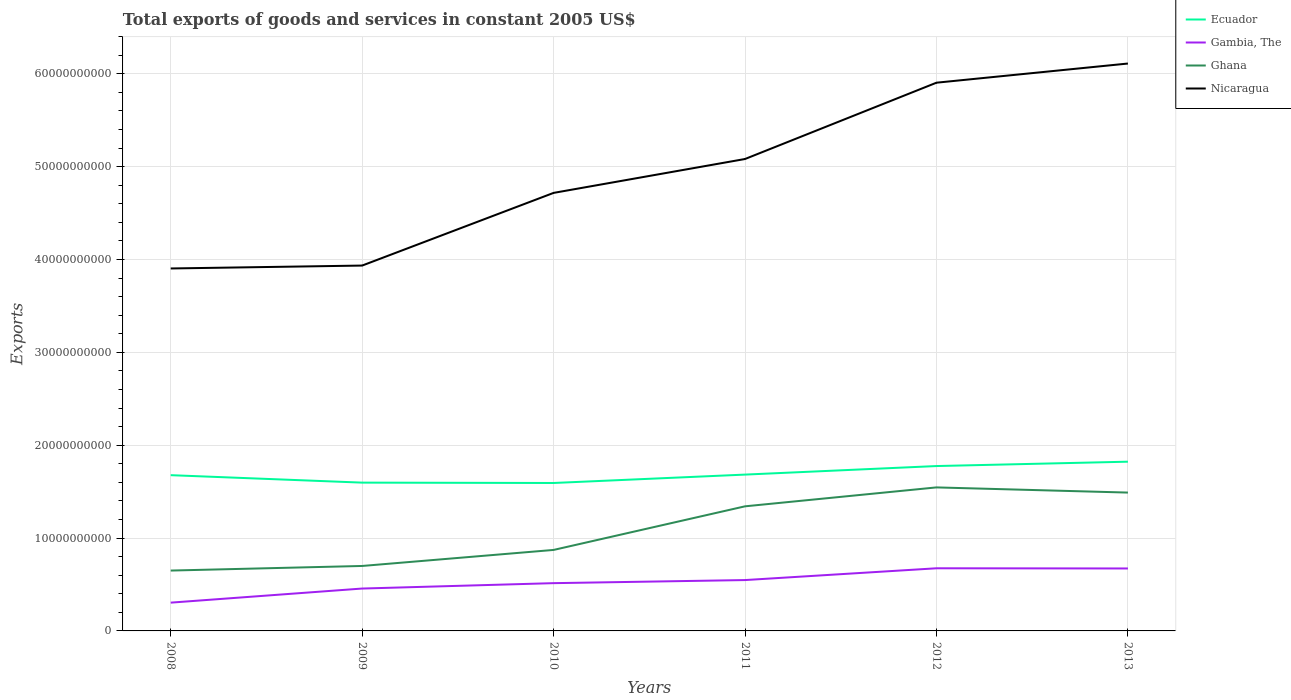Does the line corresponding to Nicaragua intersect with the line corresponding to Gambia, The?
Your response must be concise. No. Is the number of lines equal to the number of legend labels?
Your response must be concise. Yes. Across all years, what is the maximum total exports of goods and services in Ecuador?
Offer a very short reply. 1.59e+1. What is the total total exports of goods and services in Ecuador in the graph?
Your answer should be very brief. -1.39e+09. What is the difference between the highest and the second highest total exports of goods and services in Ecuador?
Provide a succinct answer. 2.29e+09. Is the total exports of goods and services in Ecuador strictly greater than the total exports of goods and services in Nicaragua over the years?
Offer a very short reply. Yes. How many lines are there?
Give a very brief answer. 4. Are the values on the major ticks of Y-axis written in scientific E-notation?
Ensure brevity in your answer.  No. Does the graph contain grids?
Your answer should be compact. Yes. Where does the legend appear in the graph?
Offer a terse response. Top right. What is the title of the graph?
Provide a succinct answer. Total exports of goods and services in constant 2005 US$. Does "Kyrgyz Republic" appear as one of the legend labels in the graph?
Your response must be concise. No. What is the label or title of the X-axis?
Keep it short and to the point. Years. What is the label or title of the Y-axis?
Provide a short and direct response. Exports. What is the Exports of Ecuador in 2008?
Keep it short and to the point. 1.68e+1. What is the Exports in Gambia, The in 2008?
Make the answer very short. 3.05e+09. What is the Exports in Ghana in 2008?
Make the answer very short. 6.50e+09. What is the Exports in Nicaragua in 2008?
Provide a short and direct response. 3.90e+1. What is the Exports of Ecuador in 2009?
Your response must be concise. 1.60e+1. What is the Exports in Gambia, The in 2009?
Your answer should be very brief. 4.56e+09. What is the Exports in Ghana in 2009?
Your response must be concise. 7.00e+09. What is the Exports of Nicaragua in 2009?
Ensure brevity in your answer.  3.93e+1. What is the Exports of Ecuador in 2010?
Your answer should be compact. 1.59e+1. What is the Exports of Gambia, The in 2010?
Keep it short and to the point. 5.14e+09. What is the Exports in Ghana in 2010?
Ensure brevity in your answer.  8.72e+09. What is the Exports in Nicaragua in 2010?
Your answer should be very brief. 4.72e+1. What is the Exports of Ecuador in 2011?
Your response must be concise. 1.68e+1. What is the Exports of Gambia, The in 2011?
Your answer should be compact. 5.48e+09. What is the Exports of Ghana in 2011?
Your answer should be compact. 1.34e+1. What is the Exports in Nicaragua in 2011?
Offer a terse response. 5.08e+1. What is the Exports in Ecuador in 2012?
Your answer should be very brief. 1.78e+1. What is the Exports of Gambia, The in 2012?
Provide a short and direct response. 6.75e+09. What is the Exports of Ghana in 2012?
Provide a short and direct response. 1.55e+1. What is the Exports in Nicaragua in 2012?
Offer a terse response. 5.90e+1. What is the Exports in Ecuador in 2013?
Offer a terse response. 1.82e+1. What is the Exports in Gambia, The in 2013?
Make the answer very short. 6.73e+09. What is the Exports in Ghana in 2013?
Provide a short and direct response. 1.49e+1. What is the Exports of Nicaragua in 2013?
Make the answer very short. 6.11e+1. Across all years, what is the maximum Exports in Ecuador?
Offer a very short reply. 1.82e+1. Across all years, what is the maximum Exports of Gambia, The?
Your response must be concise. 6.75e+09. Across all years, what is the maximum Exports in Ghana?
Your response must be concise. 1.55e+1. Across all years, what is the maximum Exports of Nicaragua?
Give a very brief answer. 6.11e+1. Across all years, what is the minimum Exports of Ecuador?
Keep it short and to the point. 1.59e+1. Across all years, what is the minimum Exports in Gambia, The?
Your answer should be very brief. 3.05e+09. Across all years, what is the minimum Exports of Ghana?
Ensure brevity in your answer.  6.50e+09. Across all years, what is the minimum Exports in Nicaragua?
Offer a very short reply. 3.90e+1. What is the total Exports in Ecuador in the graph?
Keep it short and to the point. 1.01e+11. What is the total Exports of Gambia, The in the graph?
Your response must be concise. 3.17e+1. What is the total Exports of Ghana in the graph?
Keep it short and to the point. 6.60e+1. What is the total Exports of Nicaragua in the graph?
Offer a very short reply. 2.97e+11. What is the difference between the Exports of Ecuador in 2008 and that in 2009?
Provide a short and direct response. 8.03e+08. What is the difference between the Exports of Gambia, The in 2008 and that in 2009?
Keep it short and to the point. -1.52e+09. What is the difference between the Exports of Ghana in 2008 and that in 2009?
Provide a succinct answer. -4.95e+08. What is the difference between the Exports in Nicaragua in 2008 and that in 2009?
Offer a terse response. -3.12e+08. What is the difference between the Exports of Ecuador in 2008 and that in 2010?
Offer a very short reply. 8.41e+08. What is the difference between the Exports of Gambia, The in 2008 and that in 2010?
Ensure brevity in your answer.  -2.10e+09. What is the difference between the Exports in Ghana in 2008 and that in 2010?
Your answer should be very brief. -2.22e+09. What is the difference between the Exports of Nicaragua in 2008 and that in 2010?
Your response must be concise. -8.14e+09. What is the difference between the Exports of Ecuador in 2008 and that in 2011?
Offer a terse response. -6.20e+07. What is the difference between the Exports in Gambia, The in 2008 and that in 2011?
Your answer should be very brief. -2.43e+09. What is the difference between the Exports in Ghana in 2008 and that in 2011?
Provide a short and direct response. -6.92e+09. What is the difference between the Exports in Nicaragua in 2008 and that in 2011?
Make the answer very short. -1.18e+1. What is the difference between the Exports of Ecuador in 2008 and that in 2012?
Your response must be concise. -9.82e+08. What is the difference between the Exports of Gambia, The in 2008 and that in 2012?
Provide a succinct answer. -3.70e+09. What is the difference between the Exports of Ghana in 2008 and that in 2012?
Offer a very short reply. -8.96e+09. What is the difference between the Exports in Nicaragua in 2008 and that in 2012?
Offer a very short reply. -2.00e+1. What is the difference between the Exports of Ecuador in 2008 and that in 2013?
Your answer should be very brief. -1.45e+09. What is the difference between the Exports in Gambia, The in 2008 and that in 2013?
Provide a succinct answer. -3.68e+09. What is the difference between the Exports of Ghana in 2008 and that in 2013?
Provide a succinct answer. -8.40e+09. What is the difference between the Exports in Nicaragua in 2008 and that in 2013?
Provide a succinct answer. -2.21e+1. What is the difference between the Exports in Ecuador in 2009 and that in 2010?
Give a very brief answer. 3.79e+07. What is the difference between the Exports of Gambia, The in 2009 and that in 2010?
Offer a terse response. -5.81e+08. What is the difference between the Exports of Ghana in 2009 and that in 2010?
Offer a terse response. -1.73e+09. What is the difference between the Exports of Nicaragua in 2009 and that in 2010?
Make the answer very short. -7.83e+09. What is the difference between the Exports of Ecuador in 2009 and that in 2011?
Your answer should be very brief. -8.65e+08. What is the difference between the Exports in Gambia, The in 2009 and that in 2011?
Offer a terse response. -9.14e+08. What is the difference between the Exports of Ghana in 2009 and that in 2011?
Give a very brief answer. -6.42e+09. What is the difference between the Exports of Nicaragua in 2009 and that in 2011?
Offer a very short reply. -1.15e+1. What is the difference between the Exports in Ecuador in 2009 and that in 2012?
Ensure brevity in your answer.  -1.79e+09. What is the difference between the Exports in Gambia, The in 2009 and that in 2012?
Give a very brief answer. -2.18e+09. What is the difference between the Exports in Ghana in 2009 and that in 2012?
Keep it short and to the point. -8.46e+09. What is the difference between the Exports in Nicaragua in 2009 and that in 2012?
Offer a terse response. -1.97e+1. What is the difference between the Exports of Ecuador in 2009 and that in 2013?
Your answer should be very brief. -2.26e+09. What is the difference between the Exports in Gambia, The in 2009 and that in 2013?
Provide a short and direct response. -2.16e+09. What is the difference between the Exports of Ghana in 2009 and that in 2013?
Keep it short and to the point. -7.90e+09. What is the difference between the Exports in Nicaragua in 2009 and that in 2013?
Your answer should be compact. -2.18e+1. What is the difference between the Exports of Ecuador in 2010 and that in 2011?
Make the answer very short. -9.03e+08. What is the difference between the Exports in Gambia, The in 2010 and that in 2011?
Your answer should be compact. -3.33e+08. What is the difference between the Exports in Ghana in 2010 and that in 2011?
Keep it short and to the point. -4.70e+09. What is the difference between the Exports of Nicaragua in 2010 and that in 2011?
Ensure brevity in your answer.  -3.65e+09. What is the difference between the Exports of Ecuador in 2010 and that in 2012?
Make the answer very short. -1.82e+09. What is the difference between the Exports in Gambia, The in 2010 and that in 2012?
Provide a short and direct response. -1.60e+09. What is the difference between the Exports of Ghana in 2010 and that in 2012?
Your answer should be compact. -6.73e+09. What is the difference between the Exports in Nicaragua in 2010 and that in 2012?
Provide a succinct answer. -1.19e+1. What is the difference between the Exports in Ecuador in 2010 and that in 2013?
Your response must be concise. -2.29e+09. What is the difference between the Exports of Gambia, The in 2010 and that in 2013?
Offer a terse response. -1.58e+09. What is the difference between the Exports in Ghana in 2010 and that in 2013?
Make the answer very short. -6.18e+09. What is the difference between the Exports in Nicaragua in 2010 and that in 2013?
Ensure brevity in your answer.  -1.39e+1. What is the difference between the Exports in Ecuador in 2011 and that in 2012?
Offer a terse response. -9.20e+08. What is the difference between the Exports in Gambia, The in 2011 and that in 2012?
Ensure brevity in your answer.  -1.27e+09. What is the difference between the Exports in Ghana in 2011 and that in 2012?
Keep it short and to the point. -2.04e+09. What is the difference between the Exports of Nicaragua in 2011 and that in 2012?
Offer a very short reply. -8.22e+09. What is the difference between the Exports in Ecuador in 2011 and that in 2013?
Provide a succinct answer. -1.39e+09. What is the difference between the Exports of Gambia, The in 2011 and that in 2013?
Make the answer very short. -1.25e+09. What is the difference between the Exports of Ghana in 2011 and that in 2013?
Keep it short and to the point. -1.48e+09. What is the difference between the Exports in Nicaragua in 2011 and that in 2013?
Provide a succinct answer. -1.03e+1. What is the difference between the Exports in Ecuador in 2012 and that in 2013?
Offer a terse response. -4.70e+08. What is the difference between the Exports in Ghana in 2012 and that in 2013?
Offer a very short reply. 5.57e+08. What is the difference between the Exports of Nicaragua in 2012 and that in 2013?
Make the answer very short. -2.06e+09. What is the difference between the Exports in Ecuador in 2008 and the Exports in Gambia, The in 2009?
Ensure brevity in your answer.  1.22e+1. What is the difference between the Exports in Ecuador in 2008 and the Exports in Ghana in 2009?
Offer a terse response. 9.78e+09. What is the difference between the Exports of Ecuador in 2008 and the Exports of Nicaragua in 2009?
Your answer should be very brief. -2.26e+1. What is the difference between the Exports of Gambia, The in 2008 and the Exports of Ghana in 2009?
Provide a short and direct response. -3.95e+09. What is the difference between the Exports of Gambia, The in 2008 and the Exports of Nicaragua in 2009?
Offer a terse response. -3.63e+1. What is the difference between the Exports of Ghana in 2008 and the Exports of Nicaragua in 2009?
Provide a succinct answer. -3.28e+1. What is the difference between the Exports in Ecuador in 2008 and the Exports in Gambia, The in 2010?
Make the answer very short. 1.16e+1. What is the difference between the Exports of Ecuador in 2008 and the Exports of Ghana in 2010?
Provide a succinct answer. 8.05e+09. What is the difference between the Exports of Ecuador in 2008 and the Exports of Nicaragua in 2010?
Provide a succinct answer. -3.04e+1. What is the difference between the Exports of Gambia, The in 2008 and the Exports of Ghana in 2010?
Give a very brief answer. -5.68e+09. What is the difference between the Exports in Gambia, The in 2008 and the Exports in Nicaragua in 2010?
Make the answer very short. -4.41e+1. What is the difference between the Exports of Ghana in 2008 and the Exports of Nicaragua in 2010?
Provide a short and direct response. -4.07e+1. What is the difference between the Exports in Ecuador in 2008 and the Exports in Gambia, The in 2011?
Keep it short and to the point. 1.13e+1. What is the difference between the Exports of Ecuador in 2008 and the Exports of Ghana in 2011?
Give a very brief answer. 3.35e+09. What is the difference between the Exports in Ecuador in 2008 and the Exports in Nicaragua in 2011?
Offer a very short reply. -3.41e+1. What is the difference between the Exports of Gambia, The in 2008 and the Exports of Ghana in 2011?
Keep it short and to the point. -1.04e+1. What is the difference between the Exports of Gambia, The in 2008 and the Exports of Nicaragua in 2011?
Your answer should be very brief. -4.78e+1. What is the difference between the Exports in Ghana in 2008 and the Exports in Nicaragua in 2011?
Give a very brief answer. -4.43e+1. What is the difference between the Exports in Ecuador in 2008 and the Exports in Gambia, The in 2012?
Give a very brief answer. 1.00e+1. What is the difference between the Exports in Ecuador in 2008 and the Exports in Ghana in 2012?
Provide a short and direct response. 1.32e+09. What is the difference between the Exports in Ecuador in 2008 and the Exports in Nicaragua in 2012?
Provide a succinct answer. -4.23e+1. What is the difference between the Exports of Gambia, The in 2008 and the Exports of Ghana in 2012?
Your answer should be very brief. -1.24e+1. What is the difference between the Exports of Gambia, The in 2008 and the Exports of Nicaragua in 2012?
Your answer should be very brief. -5.60e+1. What is the difference between the Exports in Ghana in 2008 and the Exports in Nicaragua in 2012?
Your answer should be compact. -5.25e+1. What is the difference between the Exports of Ecuador in 2008 and the Exports of Gambia, The in 2013?
Your response must be concise. 1.00e+1. What is the difference between the Exports in Ecuador in 2008 and the Exports in Ghana in 2013?
Provide a succinct answer. 1.87e+09. What is the difference between the Exports of Ecuador in 2008 and the Exports of Nicaragua in 2013?
Offer a very short reply. -4.43e+1. What is the difference between the Exports in Gambia, The in 2008 and the Exports in Ghana in 2013?
Your answer should be very brief. -1.19e+1. What is the difference between the Exports of Gambia, The in 2008 and the Exports of Nicaragua in 2013?
Offer a terse response. -5.81e+1. What is the difference between the Exports in Ghana in 2008 and the Exports in Nicaragua in 2013?
Your answer should be compact. -5.46e+1. What is the difference between the Exports in Ecuador in 2009 and the Exports in Gambia, The in 2010?
Offer a very short reply. 1.08e+1. What is the difference between the Exports in Ecuador in 2009 and the Exports in Ghana in 2010?
Your answer should be very brief. 7.25e+09. What is the difference between the Exports in Ecuador in 2009 and the Exports in Nicaragua in 2010?
Offer a terse response. -3.12e+1. What is the difference between the Exports in Gambia, The in 2009 and the Exports in Ghana in 2010?
Offer a terse response. -4.16e+09. What is the difference between the Exports of Gambia, The in 2009 and the Exports of Nicaragua in 2010?
Give a very brief answer. -4.26e+1. What is the difference between the Exports in Ghana in 2009 and the Exports in Nicaragua in 2010?
Provide a short and direct response. -4.02e+1. What is the difference between the Exports of Ecuador in 2009 and the Exports of Gambia, The in 2011?
Give a very brief answer. 1.05e+1. What is the difference between the Exports in Ecuador in 2009 and the Exports in Ghana in 2011?
Ensure brevity in your answer.  2.55e+09. What is the difference between the Exports in Ecuador in 2009 and the Exports in Nicaragua in 2011?
Your response must be concise. -3.49e+1. What is the difference between the Exports in Gambia, The in 2009 and the Exports in Ghana in 2011?
Make the answer very short. -8.85e+09. What is the difference between the Exports of Gambia, The in 2009 and the Exports of Nicaragua in 2011?
Provide a short and direct response. -4.63e+1. What is the difference between the Exports in Ghana in 2009 and the Exports in Nicaragua in 2011?
Provide a short and direct response. -4.38e+1. What is the difference between the Exports in Ecuador in 2009 and the Exports in Gambia, The in 2012?
Make the answer very short. 9.22e+09. What is the difference between the Exports in Ecuador in 2009 and the Exports in Ghana in 2012?
Your response must be concise. 5.14e+08. What is the difference between the Exports of Ecuador in 2009 and the Exports of Nicaragua in 2012?
Your answer should be very brief. -4.31e+1. What is the difference between the Exports of Gambia, The in 2009 and the Exports of Ghana in 2012?
Make the answer very short. -1.09e+1. What is the difference between the Exports in Gambia, The in 2009 and the Exports in Nicaragua in 2012?
Provide a short and direct response. -5.45e+1. What is the difference between the Exports of Ghana in 2009 and the Exports of Nicaragua in 2012?
Make the answer very short. -5.20e+1. What is the difference between the Exports of Ecuador in 2009 and the Exports of Gambia, The in 2013?
Give a very brief answer. 9.24e+09. What is the difference between the Exports of Ecuador in 2009 and the Exports of Ghana in 2013?
Provide a short and direct response. 1.07e+09. What is the difference between the Exports in Ecuador in 2009 and the Exports in Nicaragua in 2013?
Ensure brevity in your answer.  -4.51e+1. What is the difference between the Exports of Gambia, The in 2009 and the Exports of Ghana in 2013?
Your answer should be compact. -1.03e+1. What is the difference between the Exports of Gambia, The in 2009 and the Exports of Nicaragua in 2013?
Ensure brevity in your answer.  -5.65e+1. What is the difference between the Exports in Ghana in 2009 and the Exports in Nicaragua in 2013?
Provide a short and direct response. -5.41e+1. What is the difference between the Exports of Ecuador in 2010 and the Exports of Gambia, The in 2011?
Make the answer very short. 1.05e+1. What is the difference between the Exports in Ecuador in 2010 and the Exports in Ghana in 2011?
Make the answer very short. 2.51e+09. What is the difference between the Exports in Ecuador in 2010 and the Exports in Nicaragua in 2011?
Provide a short and direct response. -3.49e+1. What is the difference between the Exports of Gambia, The in 2010 and the Exports of Ghana in 2011?
Offer a terse response. -8.27e+09. What is the difference between the Exports in Gambia, The in 2010 and the Exports in Nicaragua in 2011?
Keep it short and to the point. -4.57e+1. What is the difference between the Exports in Ghana in 2010 and the Exports in Nicaragua in 2011?
Make the answer very short. -4.21e+1. What is the difference between the Exports of Ecuador in 2010 and the Exports of Gambia, The in 2012?
Your answer should be compact. 9.19e+09. What is the difference between the Exports of Ecuador in 2010 and the Exports of Ghana in 2012?
Offer a very short reply. 4.76e+08. What is the difference between the Exports of Ecuador in 2010 and the Exports of Nicaragua in 2012?
Give a very brief answer. -4.31e+1. What is the difference between the Exports in Gambia, The in 2010 and the Exports in Ghana in 2012?
Ensure brevity in your answer.  -1.03e+1. What is the difference between the Exports in Gambia, The in 2010 and the Exports in Nicaragua in 2012?
Your answer should be compact. -5.39e+1. What is the difference between the Exports of Ghana in 2010 and the Exports of Nicaragua in 2012?
Make the answer very short. -5.03e+1. What is the difference between the Exports in Ecuador in 2010 and the Exports in Gambia, The in 2013?
Your answer should be compact. 9.21e+09. What is the difference between the Exports of Ecuador in 2010 and the Exports of Ghana in 2013?
Provide a short and direct response. 1.03e+09. What is the difference between the Exports of Ecuador in 2010 and the Exports of Nicaragua in 2013?
Keep it short and to the point. -4.52e+1. What is the difference between the Exports in Gambia, The in 2010 and the Exports in Ghana in 2013?
Give a very brief answer. -9.75e+09. What is the difference between the Exports of Gambia, The in 2010 and the Exports of Nicaragua in 2013?
Make the answer very short. -5.60e+1. What is the difference between the Exports in Ghana in 2010 and the Exports in Nicaragua in 2013?
Make the answer very short. -5.24e+1. What is the difference between the Exports of Ecuador in 2011 and the Exports of Gambia, The in 2012?
Your response must be concise. 1.01e+1. What is the difference between the Exports of Ecuador in 2011 and the Exports of Ghana in 2012?
Offer a terse response. 1.38e+09. What is the difference between the Exports in Ecuador in 2011 and the Exports in Nicaragua in 2012?
Ensure brevity in your answer.  -4.22e+1. What is the difference between the Exports in Gambia, The in 2011 and the Exports in Ghana in 2012?
Make the answer very short. -9.98e+09. What is the difference between the Exports of Gambia, The in 2011 and the Exports of Nicaragua in 2012?
Your response must be concise. -5.36e+1. What is the difference between the Exports in Ghana in 2011 and the Exports in Nicaragua in 2012?
Keep it short and to the point. -4.56e+1. What is the difference between the Exports in Ecuador in 2011 and the Exports in Gambia, The in 2013?
Offer a terse response. 1.01e+1. What is the difference between the Exports of Ecuador in 2011 and the Exports of Ghana in 2013?
Your answer should be very brief. 1.94e+09. What is the difference between the Exports in Ecuador in 2011 and the Exports in Nicaragua in 2013?
Offer a terse response. -4.43e+1. What is the difference between the Exports of Gambia, The in 2011 and the Exports of Ghana in 2013?
Offer a terse response. -9.42e+09. What is the difference between the Exports in Gambia, The in 2011 and the Exports in Nicaragua in 2013?
Your answer should be compact. -5.56e+1. What is the difference between the Exports in Ghana in 2011 and the Exports in Nicaragua in 2013?
Ensure brevity in your answer.  -4.77e+1. What is the difference between the Exports of Ecuador in 2012 and the Exports of Gambia, The in 2013?
Keep it short and to the point. 1.10e+1. What is the difference between the Exports in Ecuador in 2012 and the Exports in Ghana in 2013?
Provide a short and direct response. 2.86e+09. What is the difference between the Exports of Ecuador in 2012 and the Exports of Nicaragua in 2013?
Give a very brief answer. -4.34e+1. What is the difference between the Exports of Gambia, The in 2012 and the Exports of Ghana in 2013?
Your answer should be very brief. -8.15e+09. What is the difference between the Exports in Gambia, The in 2012 and the Exports in Nicaragua in 2013?
Ensure brevity in your answer.  -5.44e+1. What is the difference between the Exports of Ghana in 2012 and the Exports of Nicaragua in 2013?
Your response must be concise. -4.56e+1. What is the average Exports of Ecuador per year?
Offer a very short reply. 1.69e+1. What is the average Exports in Gambia, The per year?
Offer a very short reply. 5.28e+09. What is the average Exports of Ghana per year?
Your response must be concise. 1.10e+1. What is the average Exports in Nicaragua per year?
Your answer should be compact. 4.94e+1. In the year 2008, what is the difference between the Exports of Ecuador and Exports of Gambia, The?
Keep it short and to the point. 1.37e+1. In the year 2008, what is the difference between the Exports of Ecuador and Exports of Ghana?
Give a very brief answer. 1.03e+1. In the year 2008, what is the difference between the Exports in Ecuador and Exports in Nicaragua?
Your response must be concise. -2.23e+1. In the year 2008, what is the difference between the Exports of Gambia, The and Exports of Ghana?
Make the answer very short. -3.46e+09. In the year 2008, what is the difference between the Exports of Gambia, The and Exports of Nicaragua?
Give a very brief answer. -3.60e+1. In the year 2008, what is the difference between the Exports in Ghana and Exports in Nicaragua?
Make the answer very short. -3.25e+1. In the year 2009, what is the difference between the Exports in Ecuador and Exports in Gambia, The?
Provide a succinct answer. 1.14e+1. In the year 2009, what is the difference between the Exports in Ecuador and Exports in Ghana?
Your response must be concise. 8.97e+09. In the year 2009, what is the difference between the Exports of Ecuador and Exports of Nicaragua?
Make the answer very short. -2.34e+1. In the year 2009, what is the difference between the Exports in Gambia, The and Exports in Ghana?
Offer a very short reply. -2.43e+09. In the year 2009, what is the difference between the Exports in Gambia, The and Exports in Nicaragua?
Your answer should be compact. -3.48e+1. In the year 2009, what is the difference between the Exports in Ghana and Exports in Nicaragua?
Offer a terse response. -3.24e+1. In the year 2010, what is the difference between the Exports of Ecuador and Exports of Gambia, The?
Ensure brevity in your answer.  1.08e+1. In the year 2010, what is the difference between the Exports of Ecuador and Exports of Ghana?
Offer a terse response. 7.21e+09. In the year 2010, what is the difference between the Exports of Ecuador and Exports of Nicaragua?
Give a very brief answer. -3.12e+1. In the year 2010, what is the difference between the Exports in Gambia, The and Exports in Ghana?
Make the answer very short. -3.58e+09. In the year 2010, what is the difference between the Exports of Gambia, The and Exports of Nicaragua?
Give a very brief answer. -4.20e+1. In the year 2010, what is the difference between the Exports of Ghana and Exports of Nicaragua?
Offer a very short reply. -3.85e+1. In the year 2011, what is the difference between the Exports of Ecuador and Exports of Gambia, The?
Your response must be concise. 1.14e+1. In the year 2011, what is the difference between the Exports of Ecuador and Exports of Ghana?
Keep it short and to the point. 3.42e+09. In the year 2011, what is the difference between the Exports of Ecuador and Exports of Nicaragua?
Give a very brief answer. -3.40e+1. In the year 2011, what is the difference between the Exports in Gambia, The and Exports in Ghana?
Provide a succinct answer. -7.94e+09. In the year 2011, what is the difference between the Exports in Gambia, The and Exports in Nicaragua?
Keep it short and to the point. -4.53e+1. In the year 2011, what is the difference between the Exports of Ghana and Exports of Nicaragua?
Offer a terse response. -3.74e+1. In the year 2012, what is the difference between the Exports in Ecuador and Exports in Gambia, The?
Your answer should be very brief. 1.10e+1. In the year 2012, what is the difference between the Exports in Ecuador and Exports in Ghana?
Offer a terse response. 2.30e+09. In the year 2012, what is the difference between the Exports of Ecuador and Exports of Nicaragua?
Provide a short and direct response. -4.13e+1. In the year 2012, what is the difference between the Exports of Gambia, The and Exports of Ghana?
Offer a terse response. -8.71e+09. In the year 2012, what is the difference between the Exports of Gambia, The and Exports of Nicaragua?
Make the answer very short. -5.23e+1. In the year 2012, what is the difference between the Exports of Ghana and Exports of Nicaragua?
Keep it short and to the point. -4.36e+1. In the year 2013, what is the difference between the Exports of Ecuador and Exports of Gambia, The?
Ensure brevity in your answer.  1.15e+1. In the year 2013, what is the difference between the Exports of Ecuador and Exports of Ghana?
Offer a very short reply. 3.33e+09. In the year 2013, what is the difference between the Exports in Ecuador and Exports in Nicaragua?
Ensure brevity in your answer.  -4.29e+1. In the year 2013, what is the difference between the Exports in Gambia, The and Exports in Ghana?
Ensure brevity in your answer.  -8.17e+09. In the year 2013, what is the difference between the Exports of Gambia, The and Exports of Nicaragua?
Provide a succinct answer. -5.44e+1. In the year 2013, what is the difference between the Exports of Ghana and Exports of Nicaragua?
Provide a short and direct response. -4.62e+1. What is the ratio of the Exports of Ecuador in 2008 to that in 2009?
Your answer should be compact. 1.05. What is the ratio of the Exports of Gambia, The in 2008 to that in 2009?
Keep it short and to the point. 0.67. What is the ratio of the Exports in Ghana in 2008 to that in 2009?
Offer a terse response. 0.93. What is the ratio of the Exports in Nicaragua in 2008 to that in 2009?
Keep it short and to the point. 0.99. What is the ratio of the Exports in Ecuador in 2008 to that in 2010?
Offer a terse response. 1.05. What is the ratio of the Exports of Gambia, The in 2008 to that in 2010?
Your response must be concise. 0.59. What is the ratio of the Exports of Ghana in 2008 to that in 2010?
Offer a terse response. 0.75. What is the ratio of the Exports in Nicaragua in 2008 to that in 2010?
Offer a very short reply. 0.83. What is the ratio of the Exports of Gambia, The in 2008 to that in 2011?
Offer a very short reply. 0.56. What is the ratio of the Exports in Ghana in 2008 to that in 2011?
Your response must be concise. 0.48. What is the ratio of the Exports of Nicaragua in 2008 to that in 2011?
Your answer should be compact. 0.77. What is the ratio of the Exports in Ecuador in 2008 to that in 2012?
Give a very brief answer. 0.94. What is the ratio of the Exports in Gambia, The in 2008 to that in 2012?
Keep it short and to the point. 0.45. What is the ratio of the Exports of Ghana in 2008 to that in 2012?
Offer a very short reply. 0.42. What is the ratio of the Exports in Nicaragua in 2008 to that in 2012?
Your answer should be compact. 0.66. What is the ratio of the Exports in Ecuador in 2008 to that in 2013?
Your answer should be very brief. 0.92. What is the ratio of the Exports in Gambia, The in 2008 to that in 2013?
Your answer should be very brief. 0.45. What is the ratio of the Exports of Ghana in 2008 to that in 2013?
Ensure brevity in your answer.  0.44. What is the ratio of the Exports of Nicaragua in 2008 to that in 2013?
Offer a very short reply. 0.64. What is the ratio of the Exports of Ecuador in 2009 to that in 2010?
Your answer should be compact. 1. What is the ratio of the Exports in Gambia, The in 2009 to that in 2010?
Offer a terse response. 0.89. What is the ratio of the Exports in Ghana in 2009 to that in 2010?
Keep it short and to the point. 0.8. What is the ratio of the Exports of Nicaragua in 2009 to that in 2010?
Provide a short and direct response. 0.83. What is the ratio of the Exports of Ecuador in 2009 to that in 2011?
Your answer should be very brief. 0.95. What is the ratio of the Exports of Gambia, The in 2009 to that in 2011?
Your answer should be very brief. 0.83. What is the ratio of the Exports of Ghana in 2009 to that in 2011?
Provide a succinct answer. 0.52. What is the ratio of the Exports in Nicaragua in 2009 to that in 2011?
Ensure brevity in your answer.  0.77. What is the ratio of the Exports in Ecuador in 2009 to that in 2012?
Your answer should be very brief. 0.9. What is the ratio of the Exports in Gambia, The in 2009 to that in 2012?
Your answer should be compact. 0.68. What is the ratio of the Exports in Ghana in 2009 to that in 2012?
Give a very brief answer. 0.45. What is the ratio of the Exports in Nicaragua in 2009 to that in 2012?
Your answer should be compact. 0.67. What is the ratio of the Exports in Ecuador in 2009 to that in 2013?
Keep it short and to the point. 0.88. What is the ratio of the Exports of Gambia, The in 2009 to that in 2013?
Offer a very short reply. 0.68. What is the ratio of the Exports in Ghana in 2009 to that in 2013?
Offer a very short reply. 0.47. What is the ratio of the Exports in Nicaragua in 2009 to that in 2013?
Make the answer very short. 0.64. What is the ratio of the Exports of Ecuador in 2010 to that in 2011?
Your answer should be compact. 0.95. What is the ratio of the Exports in Gambia, The in 2010 to that in 2011?
Your answer should be very brief. 0.94. What is the ratio of the Exports in Ghana in 2010 to that in 2011?
Ensure brevity in your answer.  0.65. What is the ratio of the Exports in Nicaragua in 2010 to that in 2011?
Offer a very short reply. 0.93. What is the ratio of the Exports of Ecuador in 2010 to that in 2012?
Offer a very short reply. 0.9. What is the ratio of the Exports in Gambia, The in 2010 to that in 2012?
Your response must be concise. 0.76. What is the ratio of the Exports of Ghana in 2010 to that in 2012?
Ensure brevity in your answer.  0.56. What is the ratio of the Exports of Nicaragua in 2010 to that in 2012?
Ensure brevity in your answer.  0.8. What is the ratio of the Exports in Ecuador in 2010 to that in 2013?
Provide a short and direct response. 0.87. What is the ratio of the Exports of Gambia, The in 2010 to that in 2013?
Your response must be concise. 0.76. What is the ratio of the Exports in Ghana in 2010 to that in 2013?
Ensure brevity in your answer.  0.59. What is the ratio of the Exports of Nicaragua in 2010 to that in 2013?
Offer a terse response. 0.77. What is the ratio of the Exports in Ecuador in 2011 to that in 2012?
Provide a short and direct response. 0.95. What is the ratio of the Exports of Gambia, The in 2011 to that in 2012?
Ensure brevity in your answer.  0.81. What is the ratio of the Exports in Ghana in 2011 to that in 2012?
Make the answer very short. 0.87. What is the ratio of the Exports of Nicaragua in 2011 to that in 2012?
Give a very brief answer. 0.86. What is the ratio of the Exports in Ecuador in 2011 to that in 2013?
Keep it short and to the point. 0.92. What is the ratio of the Exports of Gambia, The in 2011 to that in 2013?
Make the answer very short. 0.81. What is the ratio of the Exports of Ghana in 2011 to that in 2013?
Provide a short and direct response. 0.9. What is the ratio of the Exports of Nicaragua in 2011 to that in 2013?
Provide a short and direct response. 0.83. What is the ratio of the Exports in Ecuador in 2012 to that in 2013?
Provide a short and direct response. 0.97. What is the ratio of the Exports in Ghana in 2012 to that in 2013?
Your answer should be compact. 1.04. What is the ratio of the Exports in Nicaragua in 2012 to that in 2013?
Provide a short and direct response. 0.97. What is the difference between the highest and the second highest Exports in Ecuador?
Provide a short and direct response. 4.70e+08. What is the difference between the highest and the second highest Exports of Gambia, The?
Keep it short and to the point. 2.00e+07. What is the difference between the highest and the second highest Exports of Ghana?
Ensure brevity in your answer.  5.57e+08. What is the difference between the highest and the second highest Exports in Nicaragua?
Provide a succinct answer. 2.06e+09. What is the difference between the highest and the lowest Exports of Ecuador?
Give a very brief answer. 2.29e+09. What is the difference between the highest and the lowest Exports in Gambia, The?
Ensure brevity in your answer.  3.70e+09. What is the difference between the highest and the lowest Exports of Ghana?
Provide a succinct answer. 8.96e+09. What is the difference between the highest and the lowest Exports in Nicaragua?
Provide a succinct answer. 2.21e+1. 